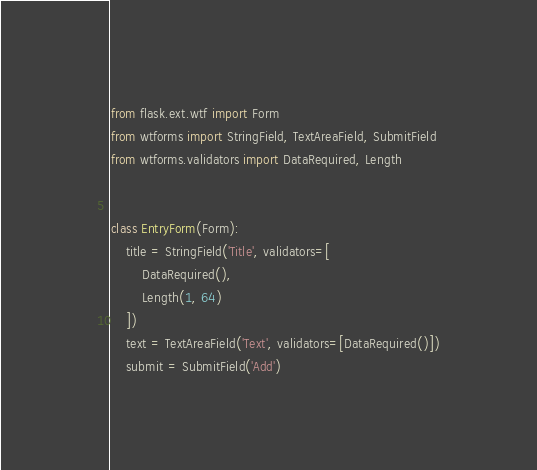Convert code to text. <code><loc_0><loc_0><loc_500><loc_500><_Python_>from flask.ext.wtf import Form
from wtforms import StringField, TextAreaField, SubmitField
from wtforms.validators import DataRequired, Length


class EntryForm(Form):
    title = StringField('Title', validators=[
        DataRequired(),
        Length(1, 64)
    ])
    text = TextAreaField('Text', validators=[DataRequired()])
    submit = SubmitField('Add')
</code> 